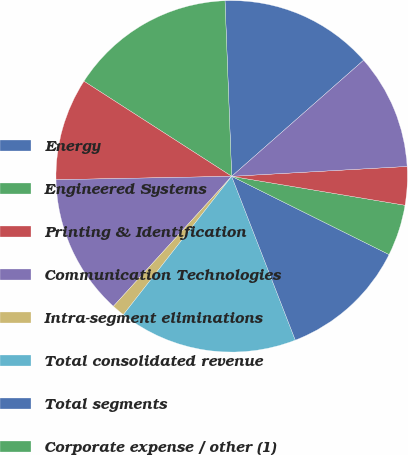Convert chart to OTSL. <chart><loc_0><loc_0><loc_500><loc_500><pie_chart><fcel>Energy<fcel>Engineered Systems<fcel>Printing & Identification<fcel>Communication Technologies<fcel>Intra-segment eliminations<fcel>Total consolidated revenue<fcel>Total segments<fcel>Corporate expense / other (1)<fcel>Net interest expense<fcel>Earnings before provision for<nl><fcel>14.12%<fcel>15.29%<fcel>9.41%<fcel>12.94%<fcel>1.18%<fcel>16.47%<fcel>11.76%<fcel>4.71%<fcel>3.53%<fcel>10.59%<nl></chart> 